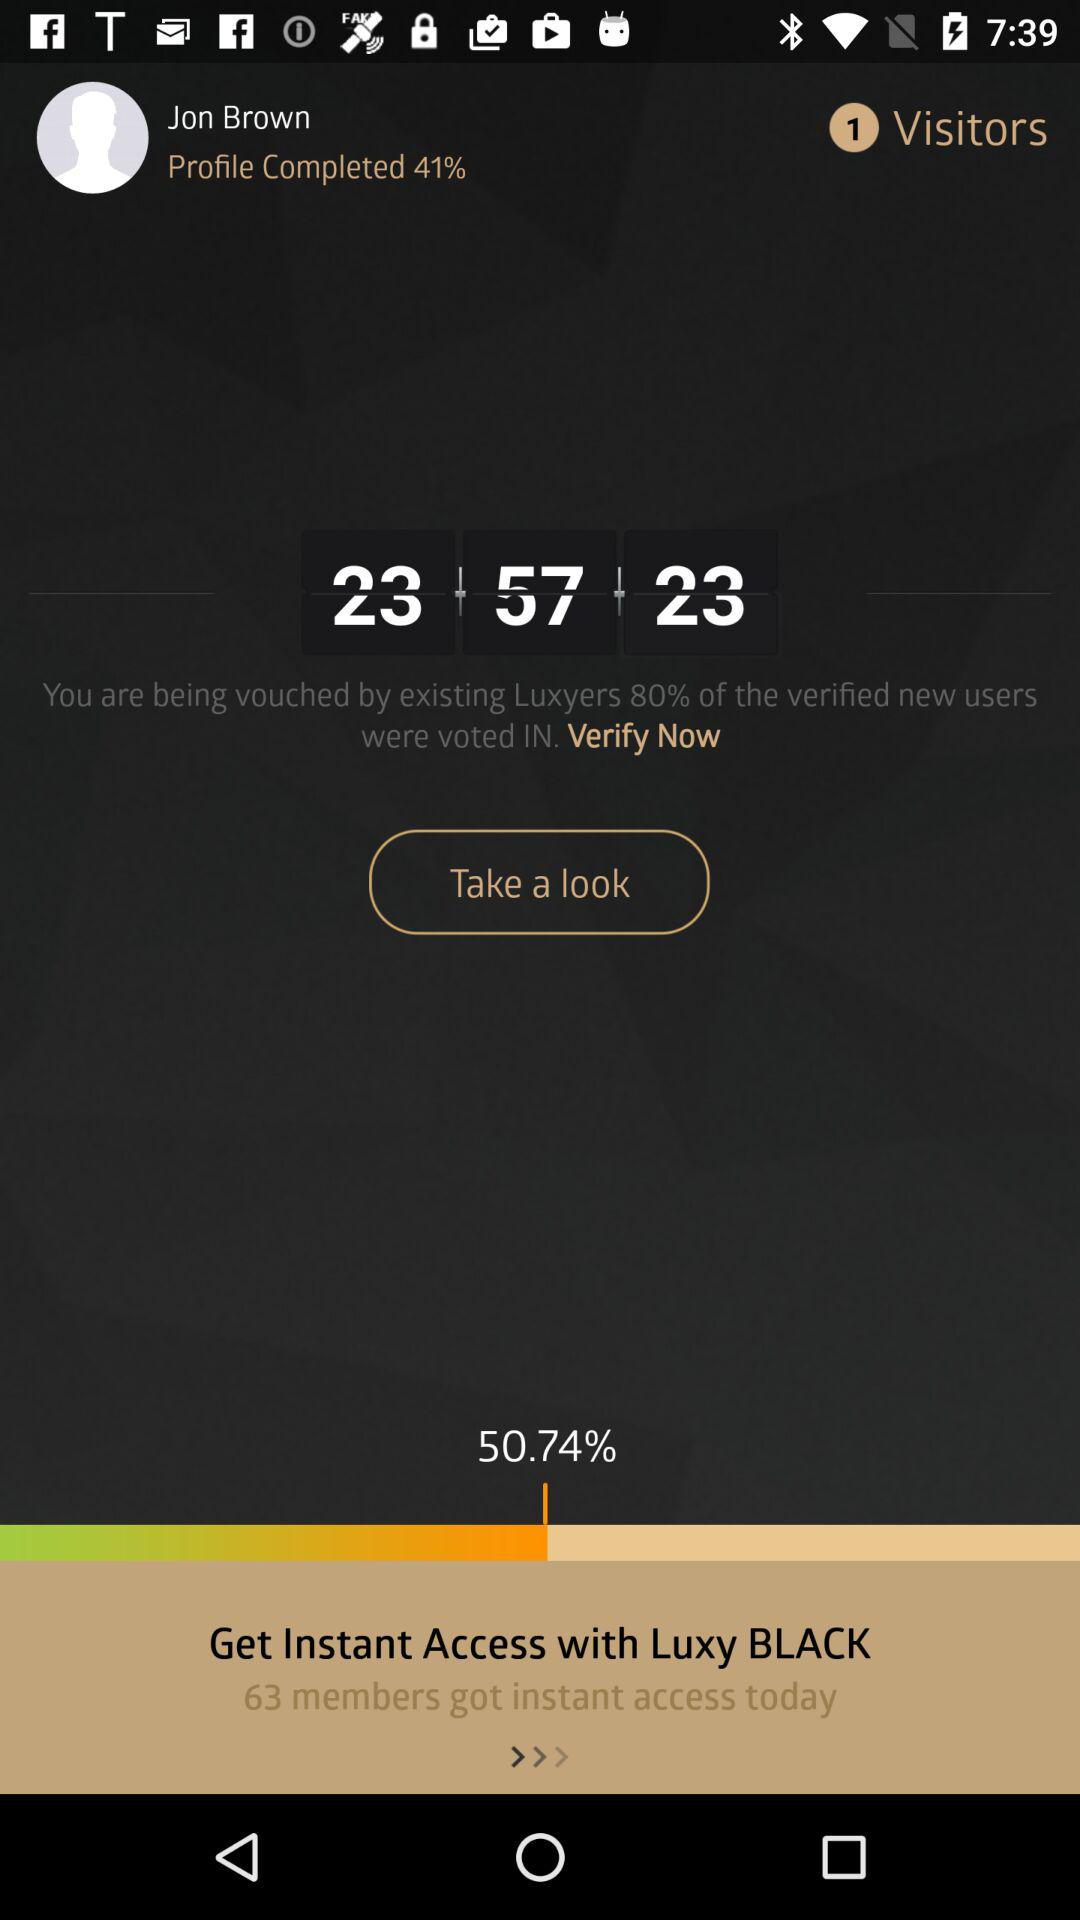How many members got instant access today? There are 63 members who got instant access today. 